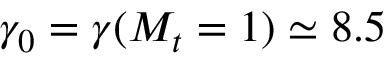Convert formula to latex. <formula><loc_0><loc_0><loc_500><loc_500>\gamma _ { 0 } = \gamma ( M _ { t } = 1 ) \simeq 8 . 5</formula> 